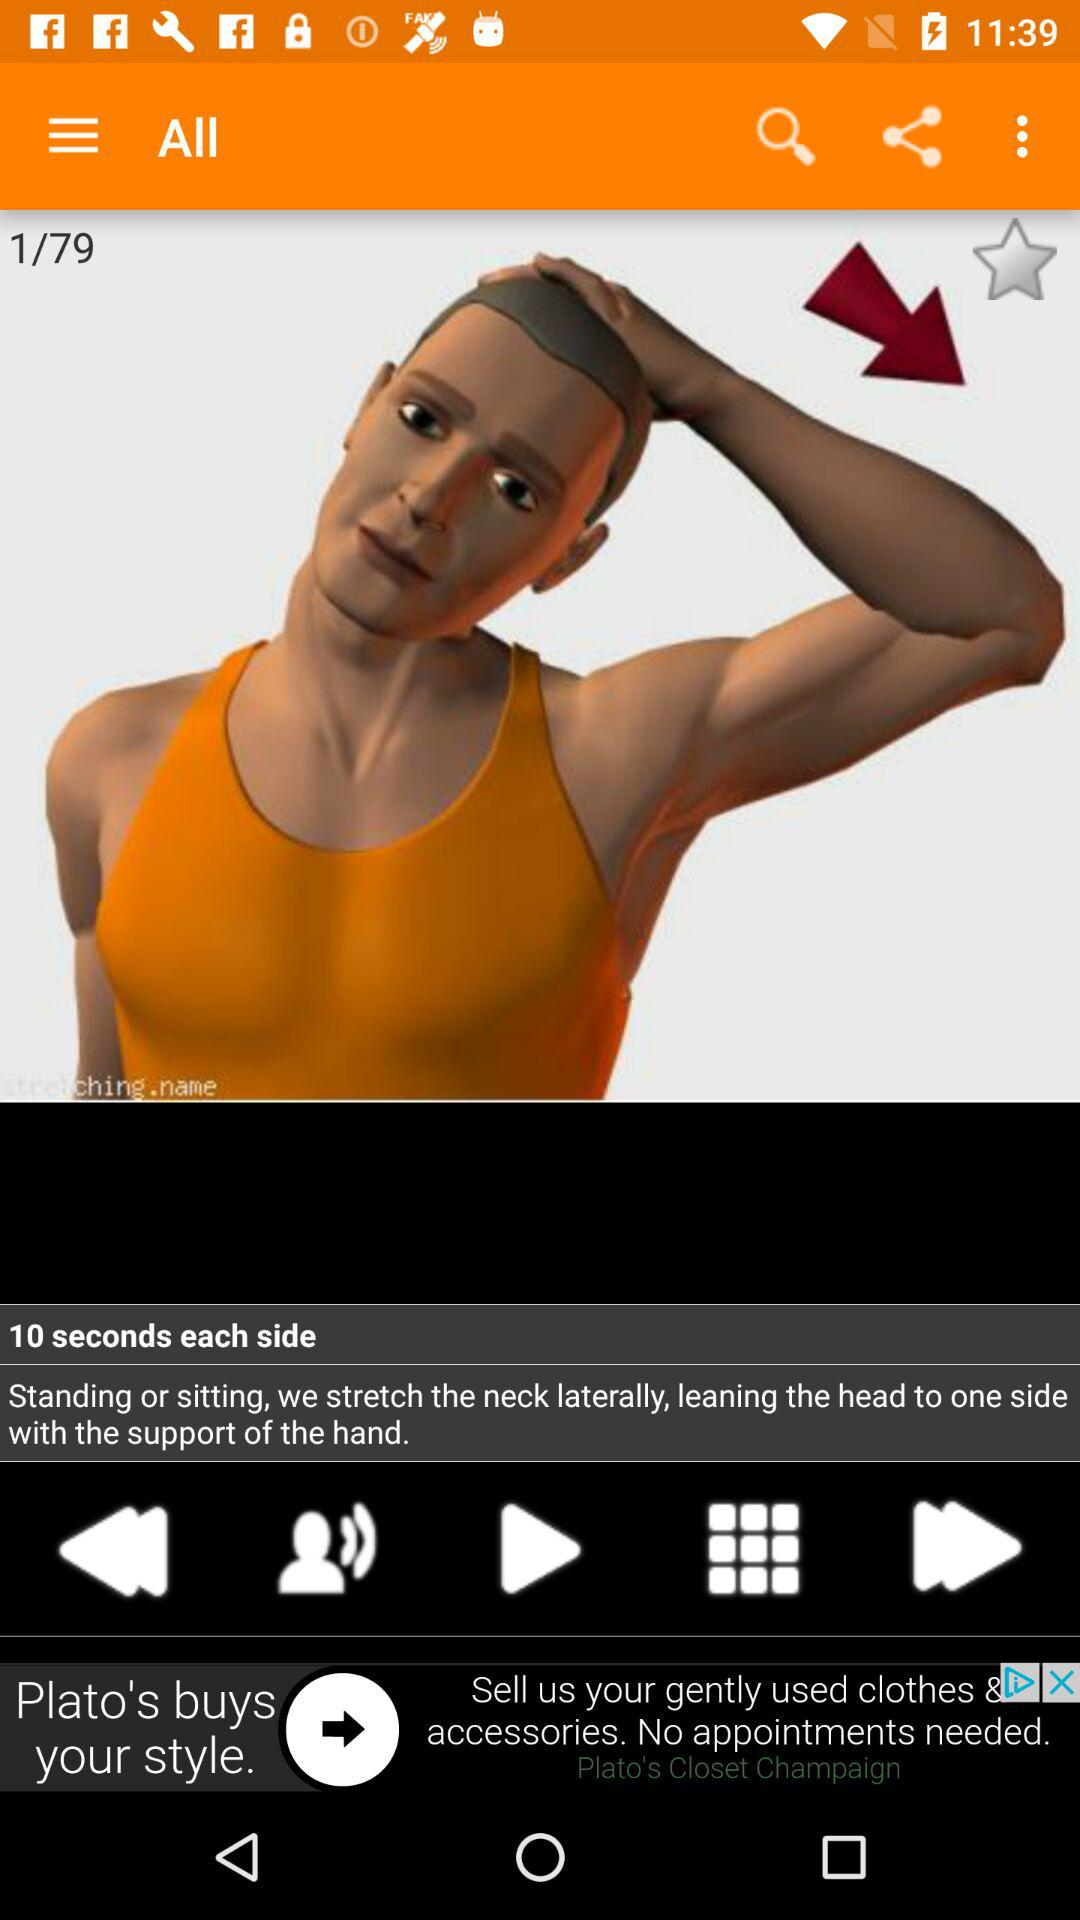At what exercise am I at? You are at exercise number 1. 